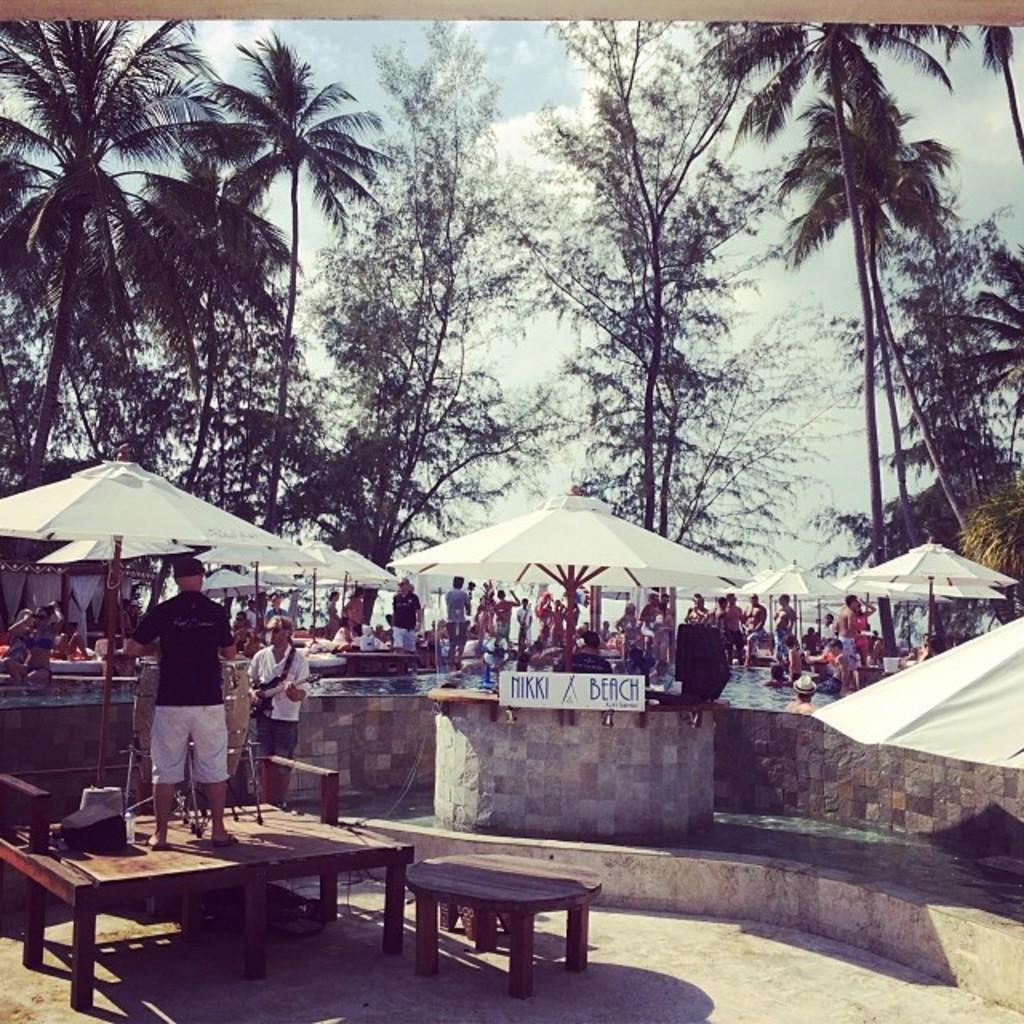What type of natural environment is visible in the image? There are trees visible in the image. What are the people in the water doing? The people in the water are likely swimming or playing. Where are the people standing on the floor? The people standing on the floor are likely on a beach or shoreline. What is the elevated surface that people are standing on in the image? There are people standing on a table in the image. What is the name of the person standing on the table in the image? There is no name provided for any of the people in the image, so it cannot be determined. 